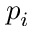Convert formula to latex. <formula><loc_0><loc_0><loc_500><loc_500>p _ { i }</formula> 